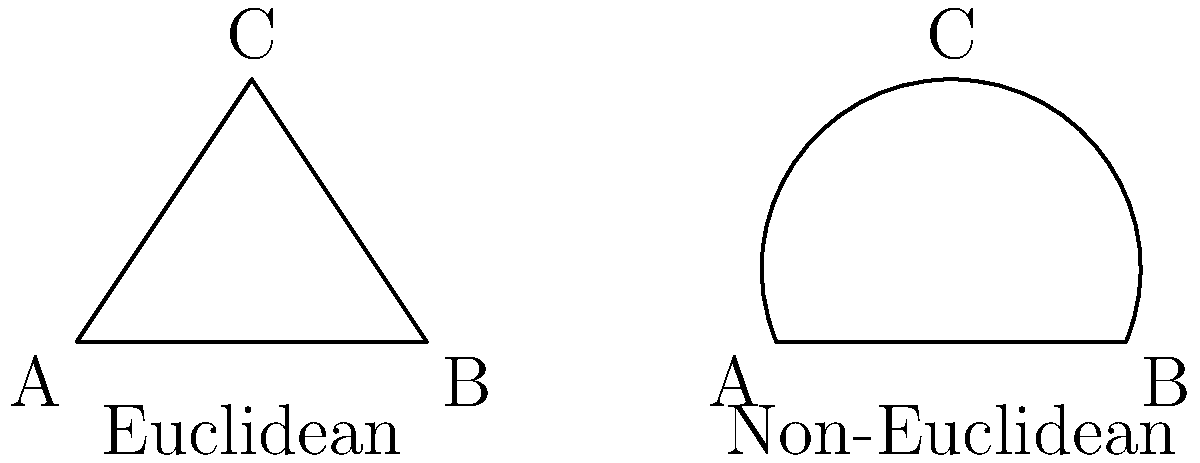As an archaeologist investigating black-market dealers, you come across an ancient artifact with peculiar geometric properties. The artifact contains two triangles: one in Euclidean space and another in a non-Euclidean (hyperbolic) space. If the sum of the interior angles of the non-Euclidean triangle is 150°, what is the difference between the angle sums of the Euclidean and non-Euclidean triangles? To solve this problem, let's follow these steps:

1. Recall the properties of triangles in Euclidean and non-Euclidean geometries:
   - In Euclidean geometry, the sum of interior angles of a triangle is always 180°.
   - In hyperbolic geometry (a type of non-Euclidean geometry), the sum of interior angles of a triangle is always less than 180°.

2. Given information:
   - The sum of interior angles of the non-Euclidean (hyperbolic) triangle is 150°.

3. Calculate the sum of interior angles for the Euclidean triangle:
   $$\text{Euclidean triangle angle sum} = 180°$$

4. Calculate the sum of interior angles for the non-Euclidean triangle:
   $$\text{Non-Euclidean triangle angle sum} = 150°$$

5. Calculate the difference between the angle sums:
   $$\text{Difference} = \text{Euclidean sum} - \text{Non-Euclidean sum}$$
   $$\text{Difference} = 180° - 150° = 30°$$

Therefore, the difference between the angle sums of the Euclidean and non-Euclidean triangles is 30°.
Answer: 30° 